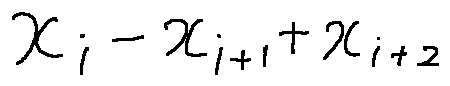<formula> <loc_0><loc_0><loc_500><loc_500>x _ { i } - x _ { i + 1 } + x _ { i + 2 }</formula> 